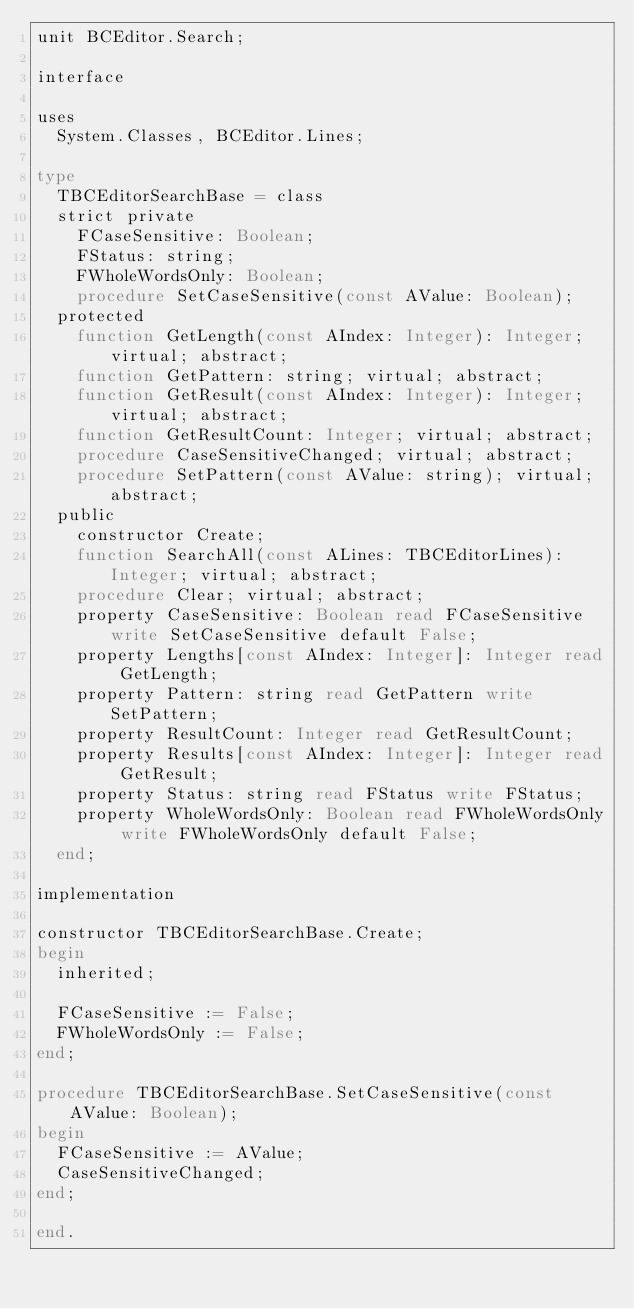Convert code to text. <code><loc_0><loc_0><loc_500><loc_500><_Pascal_>unit BCEditor.Search;

interface

uses
  System.Classes, BCEditor.Lines;

type
  TBCEditorSearchBase = class
  strict private
    FCaseSensitive: Boolean;
    FStatus: string;
    FWholeWordsOnly: Boolean;
    procedure SetCaseSensitive(const AValue: Boolean);
  protected
    function GetLength(const AIndex: Integer): Integer; virtual; abstract;
    function GetPattern: string; virtual; abstract;
    function GetResult(const AIndex: Integer): Integer; virtual; abstract;
    function GetResultCount: Integer; virtual; abstract;
    procedure CaseSensitiveChanged; virtual; abstract;
    procedure SetPattern(const AValue: string); virtual; abstract;
  public
    constructor Create;
    function SearchAll(const ALines: TBCEditorLines): Integer; virtual; abstract;
    procedure Clear; virtual; abstract;
    property CaseSensitive: Boolean read FCaseSensitive write SetCaseSensitive default False;
    property Lengths[const AIndex: Integer]: Integer read GetLength;
    property Pattern: string read GetPattern write SetPattern;
    property ResultCount: Integer read GetResultCount;
    property Results[const AIndex: Integer]: Integer read GetResult;
    property Status: string read FStatus write FStatus;
    property WholeWordsOnly: Boolean read FWholeWordsOnly write FWholeWordsOnly default False;
  end;

implementation

constructor TBCEditorSearchBase.Create;
begin
  inherited;

  FCaseSensitive := False;
  FWholeWordsOnly := False;
end;

procedure TBCEditorSearchBase.SetCaseSensitive(const AValue: Boolean);
begin
  FCaseSensitive := AValue;
  CaseSensitiveChanged;
end;

end.

</code> 